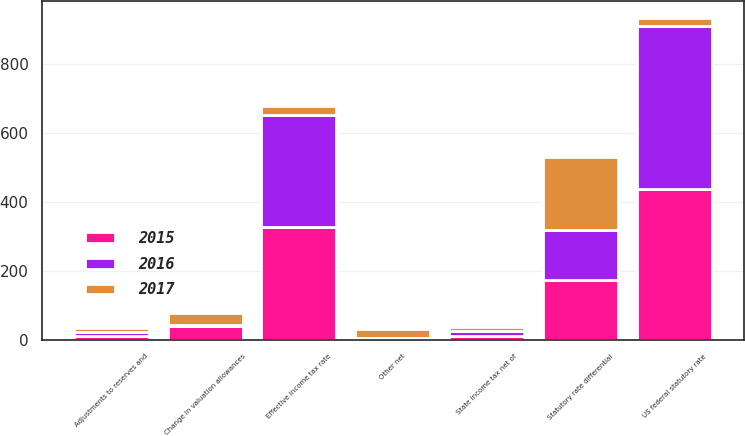Convert chart to OTSL. <chart><loc_0><loc_0><loc_500><loc_500><stacked_bar_chart><ecel><fcel>US federal statutory rate<fcel>State income tax net of<fcel>Statutory rate differential<fcel>Adjustments to reserves and<fcel>Change in valuation allowances<fcel>Other net<fcel>Effective income tax rate<nl><fcel>2017<fcel>25<fcel>11<fcel>212<fcel>12<fcel>34<fcel>25<fcel>25<nl><fcel>2016<fcel>473<fcel>15<fcel>143<fcel>11<fcel>3<fcel>4<fcel>327<nl><fcel>2015<fcel>438<fcel>12<fcel>175<fcel>13<fcel>41<fcel>2<fcel>327<nl></chart> 